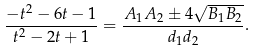<formula> <loc_0><loc_0><loc_500><loc_500>\frac { - t ^ { 2 } - 6 t - 1 } { t ^ { 2 } - 2 t + 1 } = \frac { A _ { 1 } A _ { 2 } \pm 4 \sqrt { B _ { 1 } B _ { 2 } } } { d _ { 1 } d _ { 2 } } .</formula> 